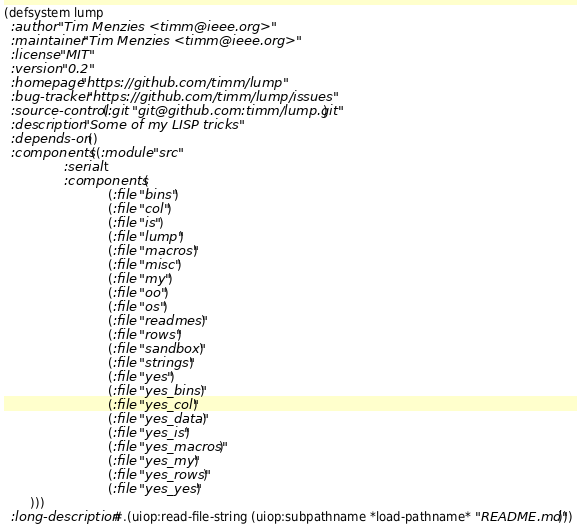Convert code to text. <code><loc_0><loc_0><loc_500><loc_500><_Lisp_>(defsystem lump
  :author "Tim Menzies <timm@ieee.org>"
  :maintainer "Tim Menzies <timm@ieee.org>"
  :license "MIT"
  :version "0.2"
  :homepage "https://github.com/timm/lump"
  :bug-tracker "https://github.com/timm/lump/issues"
  :source-control (:git "git@github.com:timm/lump.git")
  :description "Some of my LISP tricks"
  :depends-on ()
  :components ((:module "src"
                :serial t
                :components (
                            (:file "bins")
                            (:file "col")
                            (:file "is")
                            (:file "lump")
                            (:file "macros")
                            (:file "misc")
                            (:file "my")
                            (:file "oo")
                            (:file "os")
                            (:file "readmes")
                            (:file "rows")
                            (:file "sandbox")
                            (:file "strings")
                            (:file "yes")
                            (:file "yes_bins")
                            (:file "yes_col")
                            (:file "yes_data")
                            (:file "yes_is")
                            (:file "yes_macros")
                            (:file "yes_my")
                            (:file "yes_rows")
                            (:file "yes_yes")
       )))
  :long-description #.(uiop:read-file-string (uiop:subpathname *load-pathname* "README.md")))
</code> 